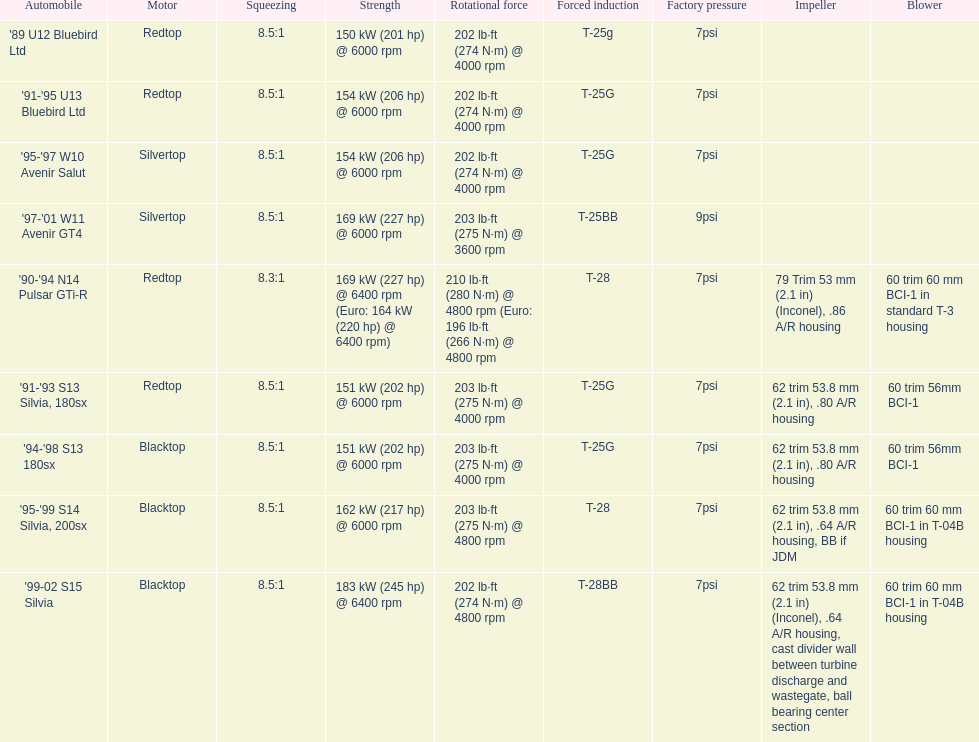Which motors are identical to the initial entry ('89 u12 bluebird ltd)? '91-'95 U13 Bluebird Ltd, '90-'94 N14 Pulsar GTi-R, '91-'93 S13 Silvia, 180sx. 